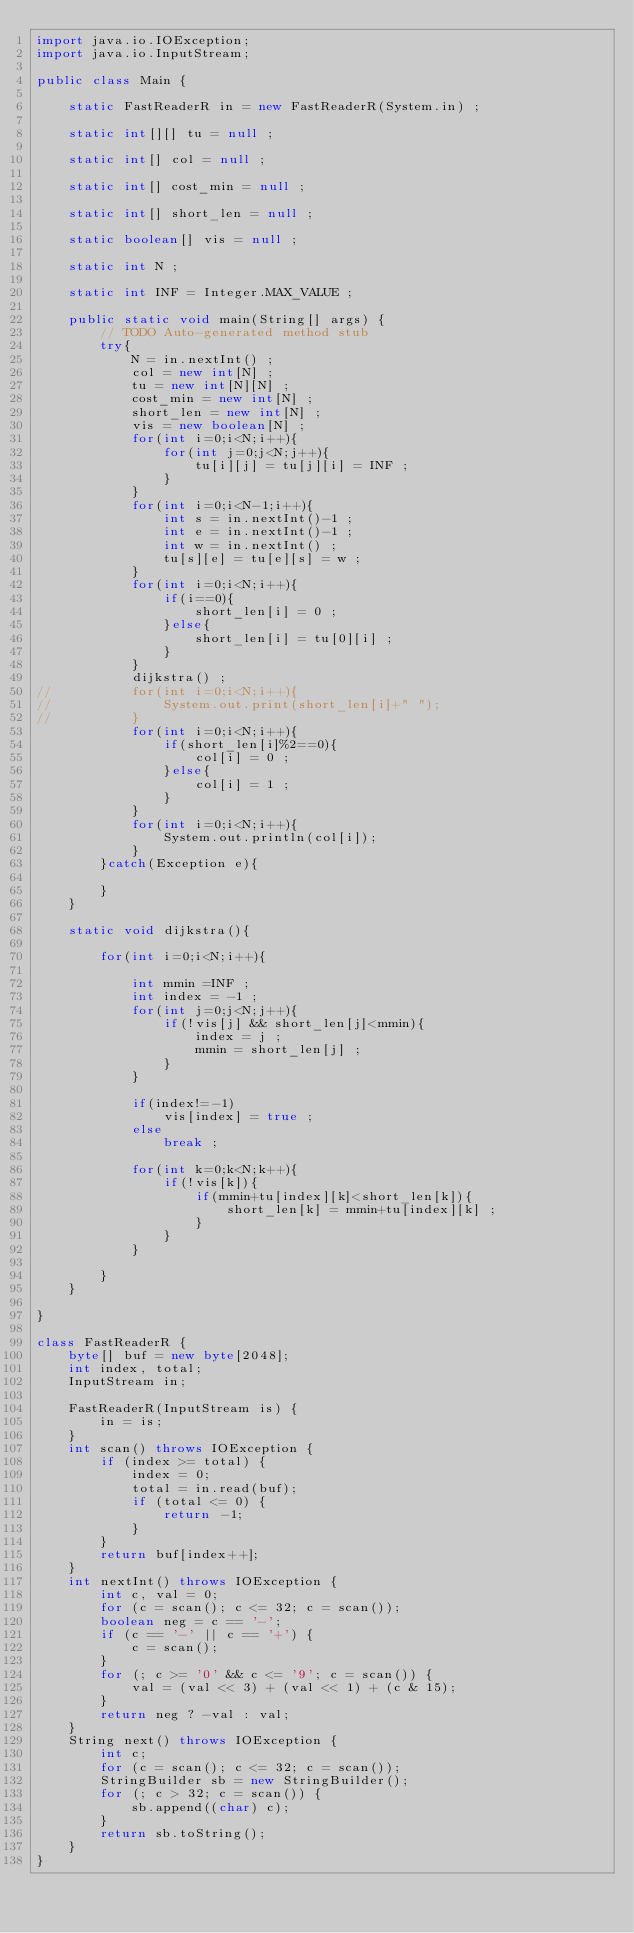<code> <loc_0><loc_0><loc_500><loc_500><_Java_>import java.io.IOException;
import java.io.InputStream;

public class Main {

	static FastReaderR in = new FastReaderR(System.in) ;
	
	static int[][] tu = null ;
	
	static int[] col = null ;
	
	static int[] cost_min = null ;
	
	static int[] short_len = null ;
	
	static boolean[] vis = null ;
	
	static int N ;
	
	static int INF = Integer.MAX_VALUE ;
	
	public static void main(String[] args) {
		// TODO Auto-generated method stub
		try{
			N = in.nextInt() ;
			col = new int[N] ;
			tu = new int[N][N] ;
			cost_min = new int[N] ;
			short_len = new int[N] ;
			vis = new boolean[N] ;
			for(int i=0;i<N;i++){
				for(int j=0;j<N;j++){
					tu[i][j] = tu[j][i] = INF ;
				}
			}
			for(int i=0;i<N-1;i++){
				int s = in.nextInt()-1 ;
				int e = in.nextInt()-1 ;
				int w = in.nextInt() ;
				tu[s][e] = tu[e][s] = w ;
			}
			for(int i=0;i<N;i++){
				if(i==0){
					short_len[i] = 0 ;
				}else{
					short_len[i] = tu[0][i] ;
				}	
			}
			dijkstra() ;
//			for(int i=0;i<N;i++){
//				System.out.print(short_len[i]+" ");
//			}
			for(int i=0;i<N;i++){
				if(short_len[i]%2==0){
					col[i] = 0 ;
				}else{
					col[i] = 1 ;
				}
			}
			for(int i=0;i<N;i++){
				System.out.println(col[i]);
			}
		}catch(Exception e){
			
		}
	}
	
	static void dijkstra(){
		
		for(int i=0;i<N;i++){
			
			int mmin =INF ;
			int index = -1 ;
			for(int j=0;j<N;j++){
				if(!vis[j] && short_len[j]<mmin){
					index = j ;
					mmin = short_len[j] ;
				}
			}
			
			if(index!=-1)
				vis[index] = true ;
			else
				break ;
			
			for(int k=0;k<N;k++){
				if(!vis[k]){
					if(mmin+tu[index][k]<short_len[k]){
						short_len[k] = mmin+tu[index][k] ;
					}
				}
			}
			
		}
	}

}

class FastReaderR {
    byte[] buf = new byte[2048];
    int index, total;
    InputStream in;
 
    FastReaderR(InputStream is) {
        in = is;
    }
    int scan() throws IOException {
        if (index >= total) {
            index = 0;
            total = in.read(buf);
            if (total <= 0) {
                return -1;
            }
        }
        return buf[index++];
    }
    int nextInt() throws IOException {
        int c, val = 0;
        for (c = scan(); c <= 32; c = scan());
        boolean neg = c == '-';
        if (c == '-' || c == '+') {
            c = scan();
        }
        for (; c >= '0' && c <= '9'; c = scan()) {
            val = (val << 3) + (val << 1) + (c & 15);
        }
        return neg ? -val : val;
    }
    String next() throws IOException {
        int c;
        for (c = scan(); c <= 32; c = scan());
        StringBuilder sb = new StringBuilder();
        for (; c > 32; c = scan()) {
            sb.append((char) c);
        }
        return sb.toString();
    }
}



</code> 